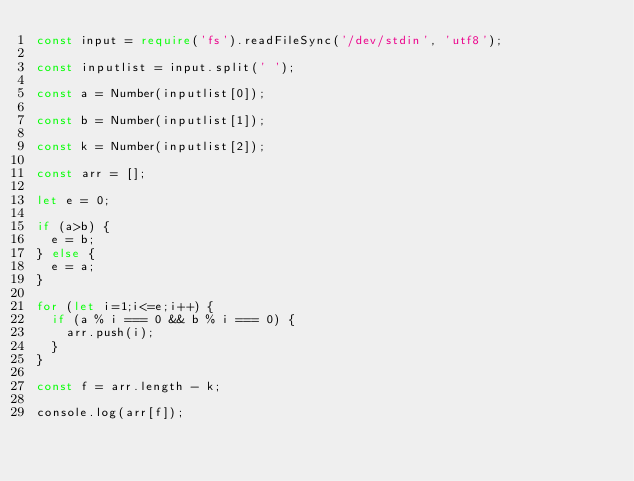Convert code to text. <code><loc_0><loc_0><loc_500><loc_500><_TypeScript_>const input = require('fs').readFileSync('/dev/stdin', 'utf8');
 
const inputlist = input.split(' ');
 
const a = Number(inputlist[0]);
 
const b = Number(inputlist[1]);
 
const k = Number(inputlist[2]);
 
const arr = [];

let e = 0;

if (a>b) {
  e = b;
} else {
  e = a;
}
 
for (let i=1;i<=e;i++) {
  if (a % i === 0 && b % i === 0) {
    arr.push(i);
  }
}

const f = arr.length - k;
 
console.log(arr[f]);</code> 